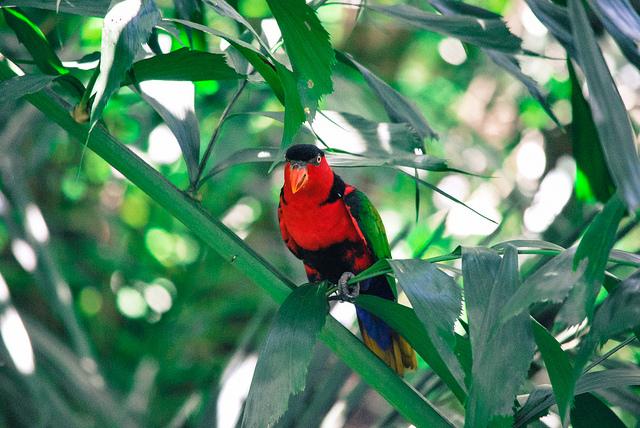What color is the bird's face?
Be succinct. Red. How many birds are in the picture?
Short answer required. 1. How many eyes are there?
Be succinct. 2. What color stands out?
Concise answer only. Red. What color are the birds?
Answer briefly. Red. 